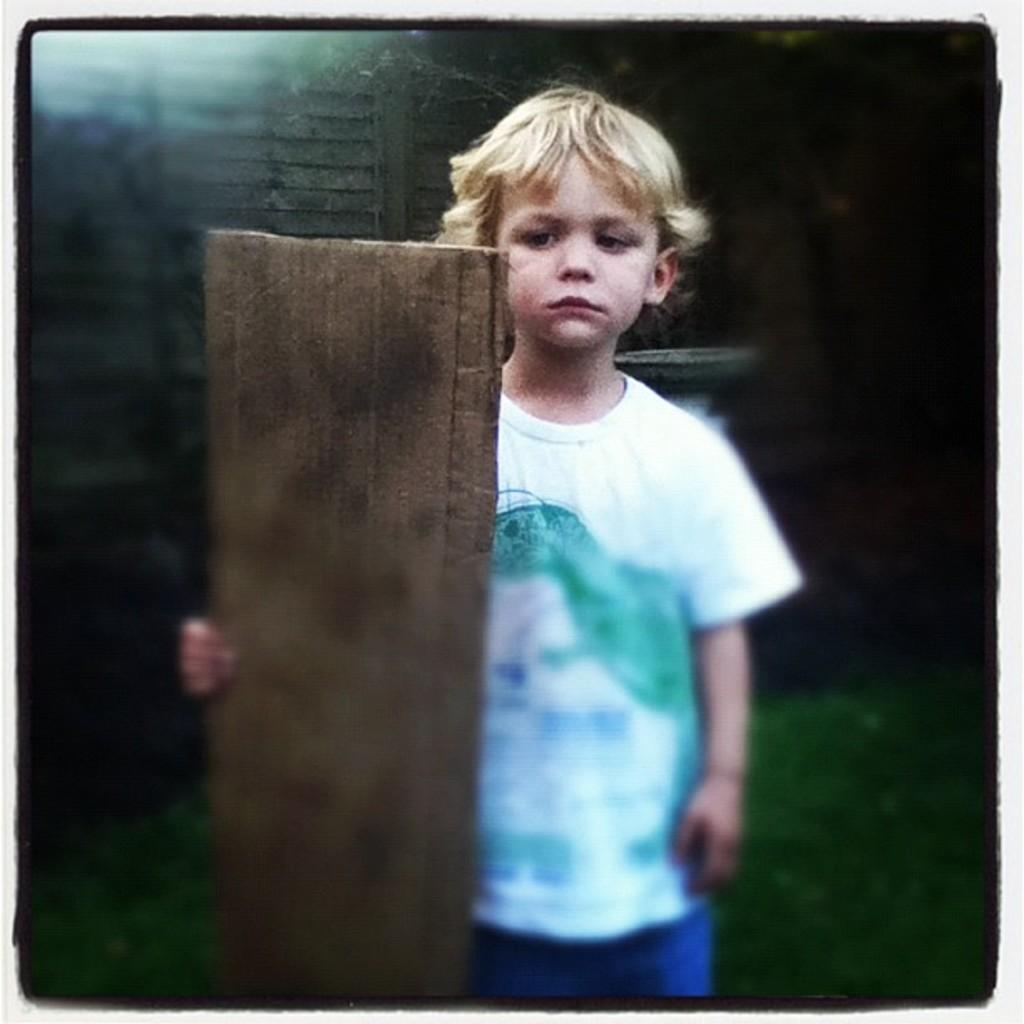What is the main subject of the image? The main subject of the image is a boy. What is the boy doing in the image? The boy is standing in the image. What object is the boy holding in his hand? The boy is holding a board in his hand. What type of toad can be seen sitting on the boy's shoulder in the image? There is no toad present on the boy's shoulder in the image. What type of flesh is visible on the boy's arm in the image? The image does not show any flesh on the boy's arm, only the boy holding a board. 